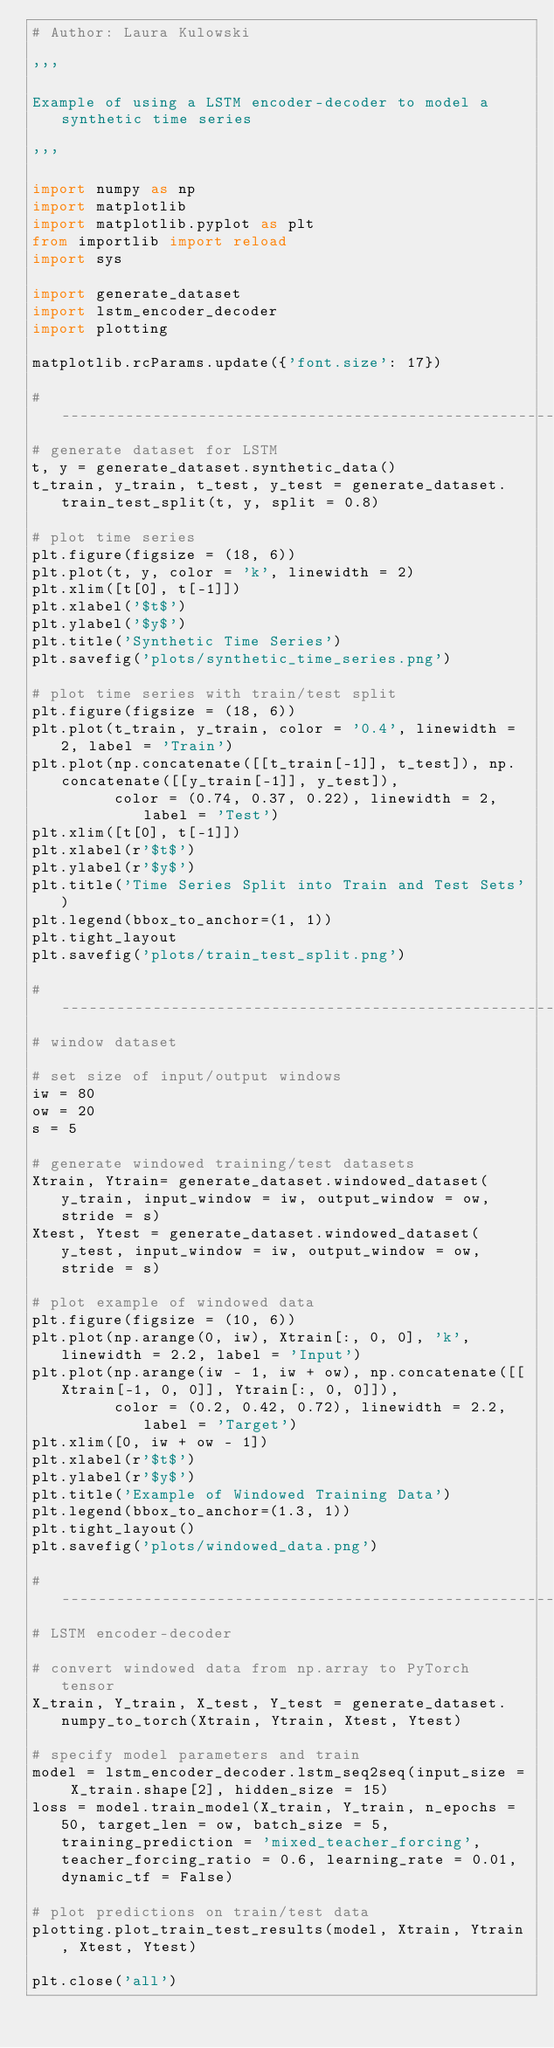Convert code to text. <code><loc_0><loc_0><loc_500><loc_500><_Python_># Author: Laura Kulowski

'''

Example of using a LSTM encoder-decoder to model a synthetic time series 

'''

import numpy as np
import matplotlib
import matplotlib.pyplot as plt
from importlib import reload
import sys

import generate_dataset
import lstm_encoder_decoder
import plotting 

matplotlib.rcParams.update({'font.size': 17})

#----------------------------------------------------------------------------------------------------------------
# generate dataset for LSTM
t, y = generate_dataset.synthetic_data()
t_train, y_train, t_test, y_test = generate_dataset.train_test_split(t, y, split = 0.8)

# plot time series 
plt.figure(figsize = (18, 6))
plt.plot(t, y, color = 'k', linewidth = 2)
plt.xlim([t[0], t[-1]])
plt.xlabel('$t$')
plt.ylabel('$y$')
plt.title('Synthetic Time Series')
plt.savefig('plots/synthetic_time_series.png')

# plot time series with train/test split
plt.figure(figsize = (18, 6))
plt.plot(t_train, y_train, color = '0.4', linewidth = 2, label = 'Train') 
plt.plot(np.concatenate([[t_train[-1]], t_test]), np.concatenate([[y_train[-1]], y_test]),
         color = (0.74, 0.37, 0.22), linewidth = 2, label = 'Test')
plt.xlim([t[0], t[-1]])
plt.xlabel(r'$t$')
plt.ylabel(r'$y$')
plt.title('Time Series Split into Train and Test Sets')
plt.legend(bbox_to_anchor=(1, 1))
plt.tight_layout
plt.savefig('plots/train_test_split.png')

#----------------------------------------------------------------------------------------------------------------
# window dataset

# set size of input/output windows 
iw = 80 
ow = 20 
s = 5

# generate windowed training/test datasets
Xtrain, Ytrain= generate_dataset.windowed_dataset(y_train, input_window = iw, output_window = ow, stride = s)
Xtest, Ytest = generate_dataset.windowed_dataset(y_test, input_window = iw, output_window = ow, stride = s)

# plot example of windowed data  
plt.figure(figsize = (10, 6)) 
plt.plot(np.arange(0, iw), Xtrain[:, 0, 0], 'k', linewidth = 2.2, label = 'Input')
plt.plot(np.arange(iw - 1, iw + ow), np.concatenate([[Xtrain[-1, 0, 0]], Ytrain[:, 0, 0]]),
         color = (0.2, 0.42, 0.72), linewidth = 2.2, label = 'Target')
plt.xlim([0, iw + ow - 1])
plt.xlabel(r'$t$')
plt.ylabel(r'$y$')
plt.title('Example of Windowed Training Data')
plt.legend(bbox_to_anchor=(1.3, 1))
plt.tight_layout() 
plt.savefig('plots/windowed_data.png')

#----------------------------------------------------------------------------------------------------------------
# LSTM encoder-decoder

# convert windowed data from np.array to PyTorch tensor
X_train, Y_train, X_test, Y_test = generate_dataset.numpy_to_torch(Xtrain, Ytrain, Xtest, Ytest)

# specify model parameters and train
model = lstm_encoder_decoder.lstm_seq2seq(input_size = X_train.shape[2], hidden_size = 15)
loss = model.train_model(X_train, Y_train, n_epochs = 50, target_len = ow, batch_size = 5, training_prediction = 'mixed_teacher_forcing', teacher_forcing_ratio = 0.6, learning_rate = 0.01, dynamic_tf = False)

# plot predictions on train/test data
plotting.plot_train_test_results(model, Xtrain, Ytrain, Xtest, Ytest)

plt.close('all')

</code> 